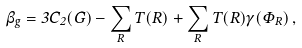Convert formula to latex. <formula><loc_0><loc_0><loc_500><loc_500>\beta _ { g } = 3 C _ { 2 } ( G ) - \sum _ { R } T ( R ) + \sum _ { R } T ( R ) \gamma ( \varPhi _ { R } ) \, ,</formula> 